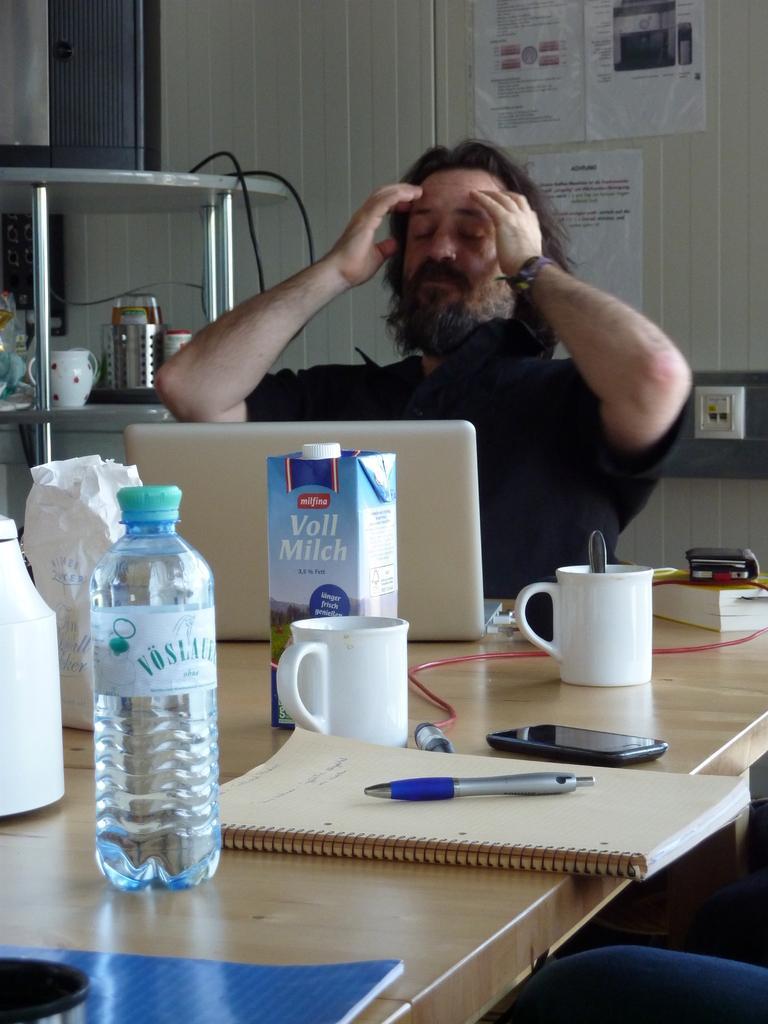Please provide a concise description of this image. In this image there is one person who is sitting and looking at laptop and in front of him there is one table. On the table there is one bottle and two cups, one book, pen and one mobile phone is there on the table. On the right side there is one book on the left side of the top corner there is one cupboard and one cup on it on the top of the right corner there are three posters. 